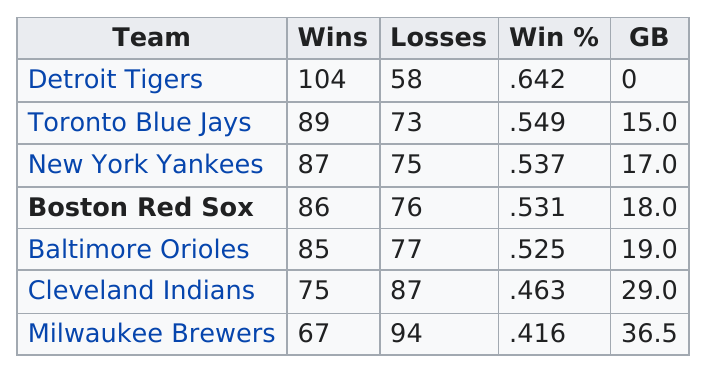Identify some key points in this picture. The team with the lowest win percentage is the Milwaukee Brewers. The Detroit Tigers are a team with at least 100 wins. The Detroit Tigers were the only team to win more than 100 games, achieving a remarkable record of victory. The Detroit Tigers had the least amount of losses among all teams. In the last 10 years, how many teams have won 75 games or fewer? 